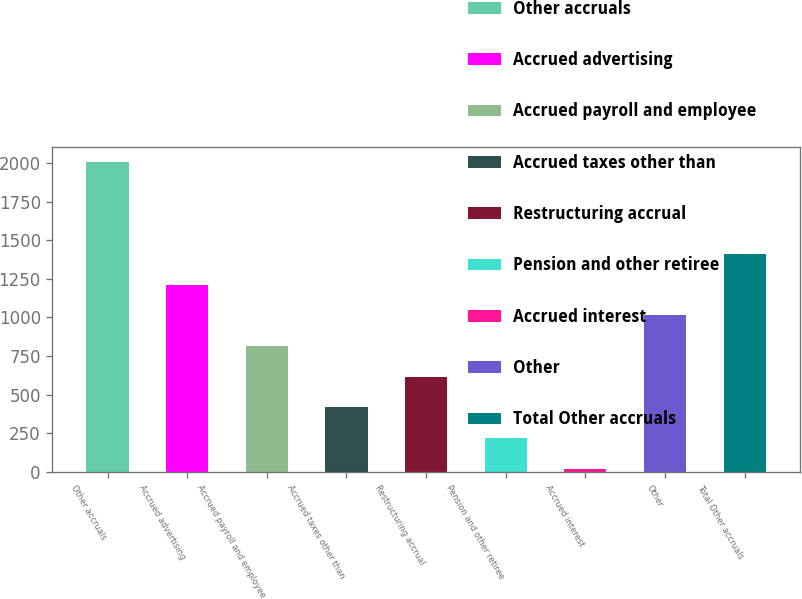Convert chart to OTSL. <chart><loc_0><loc_0><loc_500><loc_500><bar_chart><fcel>Other accruals<fcel>Accrued advertising<fcel>Accrued payroll and employee<fcel>Accrued taxes other than<fcel>Restructuring accrual<fcel>Pension and other retiree<fcel>Accrued interest<fcel>Other<fcel>Total Other accruals<nl><fcel>2006<fcel>1211.24<fcel>813.86<fcel>416.48<fcel>615.17<fcel>217.79<fcel>19.1<fcel>1012.55<fcel>1409.93<nl></chart> 